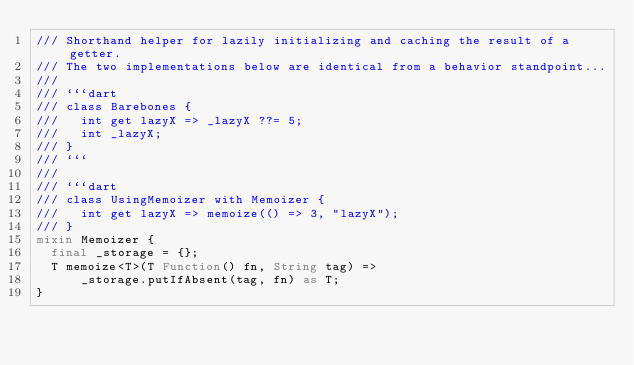Convert code to text. <code><loc_0><loc_0><loc_500><loc_500><_Dart_>/// Shorthand helper for lazily initializing and caching the result of a getter.
/// The two implementations below are identical from a behavior standpoint...
///
/// ```dart
/// class Barebones {
///   int get lazyX => _lazyX ??= 5;
///   int _lazyX;
/// }
/// ```
///
/// ```dart
/// class UsingMemoizer with Memoizer {
///   int get lazyX => memoize(() => 3, "lazyX");
/// }
mixin Memoizer {
  final _storage = {};
  T memoize<T>(T Function() fn, String tag) =>
      _storage.putIfAbsent(tag, fn) as T;
}
</code> 